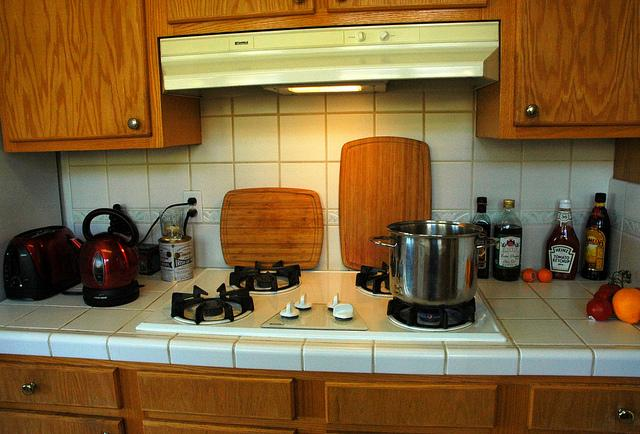What is a favorite condiment of the owner?

Choices:
A) soy sauce
B) mustard
C) relish
D) ketchup ketchup 